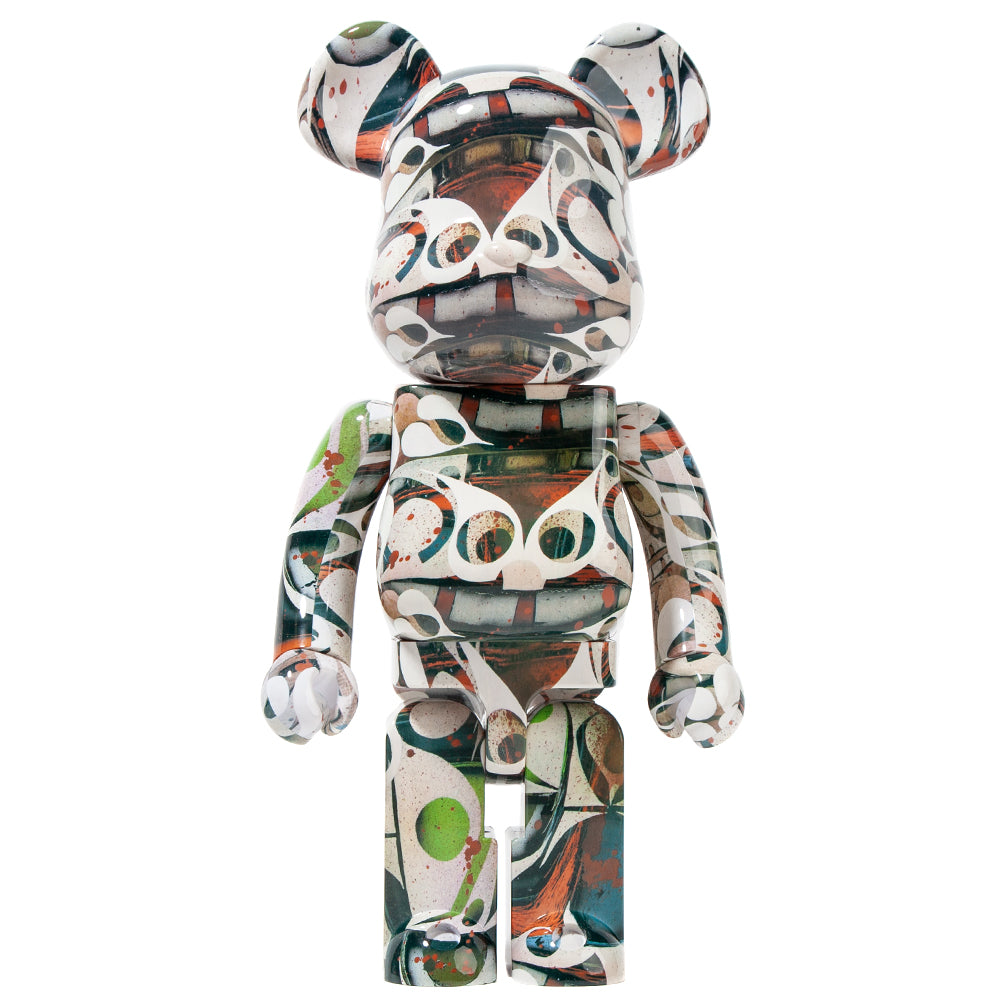What might the choice of colors and abstract patterns on the figurine's surface suggest about the intended artistic influence or style represented by this object? The choice of colors and abstract patterns on the figurine’s surface suggests an artistic influence that embraces spontaneity and emotional expression, embodying characteristics often associated with movements like abstract expressionism. The dynamic and seemingly random splatters of paint could point towards an inspiration from artists such as Jackson Pollock, who is celebrated for his drip painting techniques. The vibrant mix of colors, intersecting swirls, and free-form patterns convey a sense of liveliness, spontaneity, and creativity, indicating a style aimed at breaking away from traditional representational forms. Essentially, the figurine's design appears to emphasize artistic freedom, innovation, and an unrestrained creative process. 